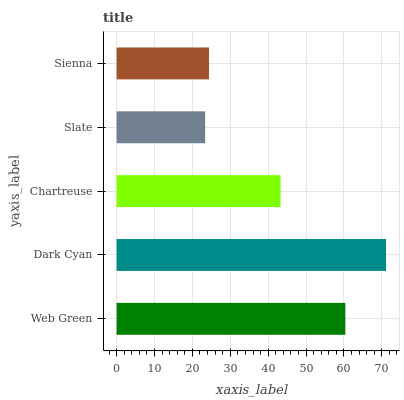Is Slate the minimum?
Answer yes or no. Yes. Is Dark Cyan the maximum?
Answer yes or no. Yes. Is Chartreuse the minimum?
Answer yes or no. No. Is Chartreuse the maximum?
Answer yes or no. No. Is Dark Cyan greater than Chartreuse?
Answer yes or no. Yes. Is Chartreuse less than Dark Cyan?
Answer yes or no. Yes. Is Chartreuse greater than Dark Cyan?
Answer yes or no. No. Is Dark Cyan less than Chartreuse?
Answer yes or no. No. Is Chartreuse the high median?
Answer yes or no. Yes. Is Chartreuse the low median?
Answer yes or no. Yes. Is Sienna the high median?
Answer yes or no. No. Is Dark Cyan the low median?
Answer yes or no. No. 